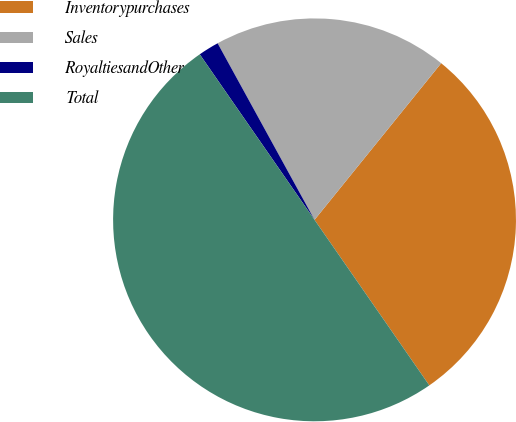Convert chart. <chart><loc_0><loc_0><loc_500><loc_500><pie_chart><fcel>Inventorypurchases<fcel>Sales<fcel>RoyaltiesandOther<fcel>Total<nl><fcel>29.53%<fcel>18.81%<fcel>1.66%<fcel>50.0%<nl></chart> 